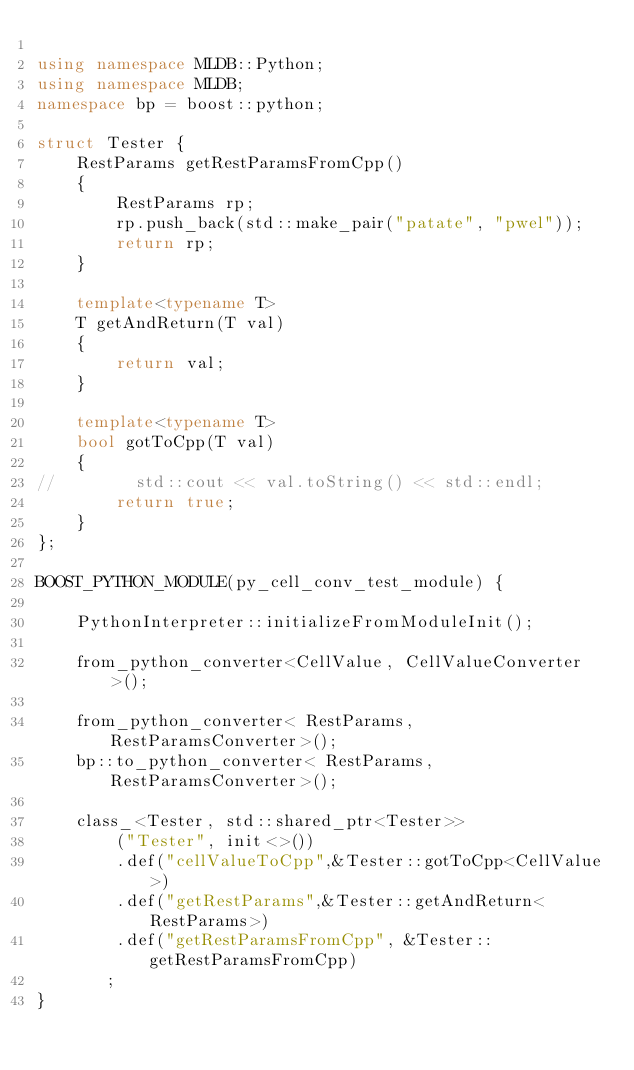Convert code to text. <code><loc_0><loc_0><loc_500><loc_500><_C++_>
using namespace MLDB::Python;
using namespace MLDB;
namespace bp = boost::python;

struct Tester {
    RestParams getRestParamsFromCpp()
    {
        RestParams rp;
        rp.push_back(std::make_pair("patate", "pwel"));
        return rp;
    }

    template<typename T>
    T getAndReturn(T val)
    {
        return val;
    }

    template<typename T>
    bool gotToCpp(T val)
    {
//        std::cout << val.toString() << std::endl;
        return true;
    }
};

BOOST_PYTHON_MODULE(py_cell_conv_test_module) {

    PythonInterpreter::initializeFromModuleInit();

    from_python_converter<CellValue, CellValueConverter>();

    from_python_converter< RestParams, RestParamsConverter>();
    bp::to_python_converter< RestParams, RestParamsConverter>();

    class_<Tester, std::shared_ptr<Tester>>
        ("Tester", init<>())
        .def("cellValueToCpp",&Tester::gotToCpp<CellValue>)
        .def("getRestParams",&Tester::getAndReturn<RestParams>)
        .def("getRestParamsFromCpp", &Tester::getRestParamsFromCpp)
       ;
}
</code> 